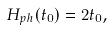Convert formula to latex. <formula><loc_0><loc_0><loc_500><loc_500>H _ { p h } ( t _ { 0 } ) = 2 t _ { 0 } ,</formula> 